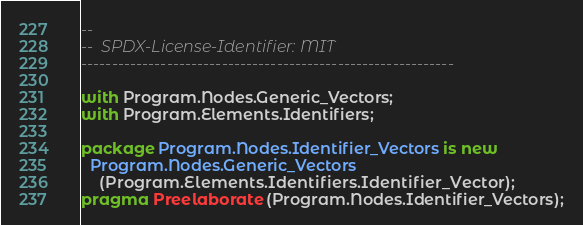<code> <loc_0><loc_0><loc_500><loc_500><_Ada_>--
--  SPDX-License-Identifier: MIT
-------------------------------------------------------------

with Program.Nodes.Generic_Vectors;
with Program.Elements.Identifiers;

package Program.Nodes.Identifier_Vectors is new
  Program.Nodes.Generic_Vectors
    (Program.Elements.Identifiers.Identifier_Vector);
pragma Preelaborate (Program.Nodes.Identifier_Vectors);
</code> 